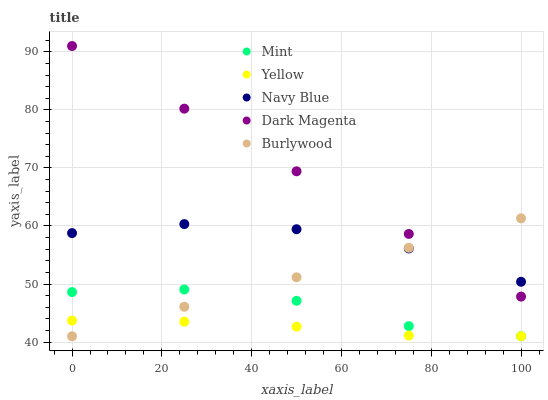Does Yellow have the minimum area under the curve?
Answer yes or no. Yes. Does Dark Magenta have the maximum area under the curve?
Answer yes or no. Yes. Does Navy Blue have the minimum area under the curve?
Answer yes or no. No. Does Navy Blue have the maximum area under the curve?
Answer yes or no. No. Is Burlywood the smoothest?
Answer yes or no. Yes. Is Mint the roughest?
Answer yes or no. Yes. Is Navy Blue the smoothest?
Answer yes or no. No. Is Navy Blue the roughest?
Answer yes or no. No. Does Burlywood have the lowest value?
Answer yes or no. Yes. Does Navy Blue have the lowest value?
Answer yes or no. No. Does Dark Magenta have the highest value?
Answer yes or no. Yes. Does Navy Blue have the highest value?
Answer yes or no. No. Is Yellow less than Navy Blue?
Answer yes or no. Yes. Is Navy Blue greater than Yellow?
Answer yes or no. Yes. Does Burlywood intersect Navy Blue?
Answer yes or no. Yes. Is Burlywood less than Navy Blue?
Answer yes or no. No. Is Burlywood greater than Navy Blue?
Answer yes or no. No. Does Yellow intersect Navy Blue?
Answer yes or no. No. 